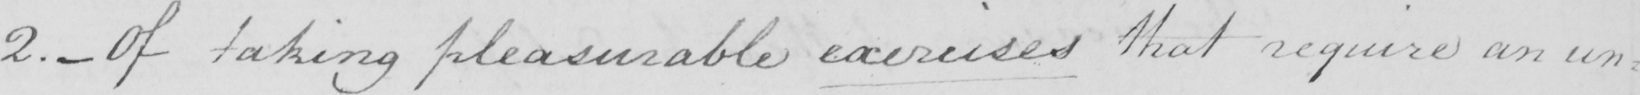Please provide the text content of this handwritten line. 2 .  _  Of taking pleasurable exercises that require an un= 